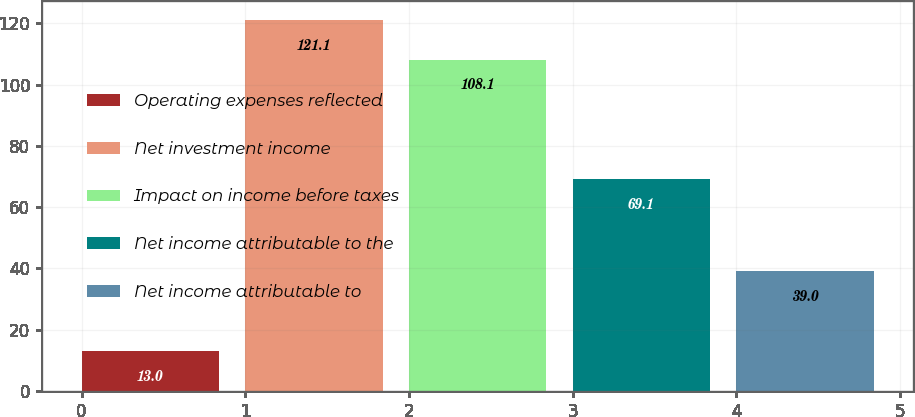Convert chart. <chart><loc_0><loc_0><loc_500><loc_500><bar_chart><fcel>Operating expenses reflected<fcel>Net investment income<fcel>Impact on income before taxes<fcel>Net income attributable to the<fcel>Net income attributable to<nl><fcel>13<fcel>121.1<fcel>108.1<fcel>69.1<fcel>39<nl></chart> 